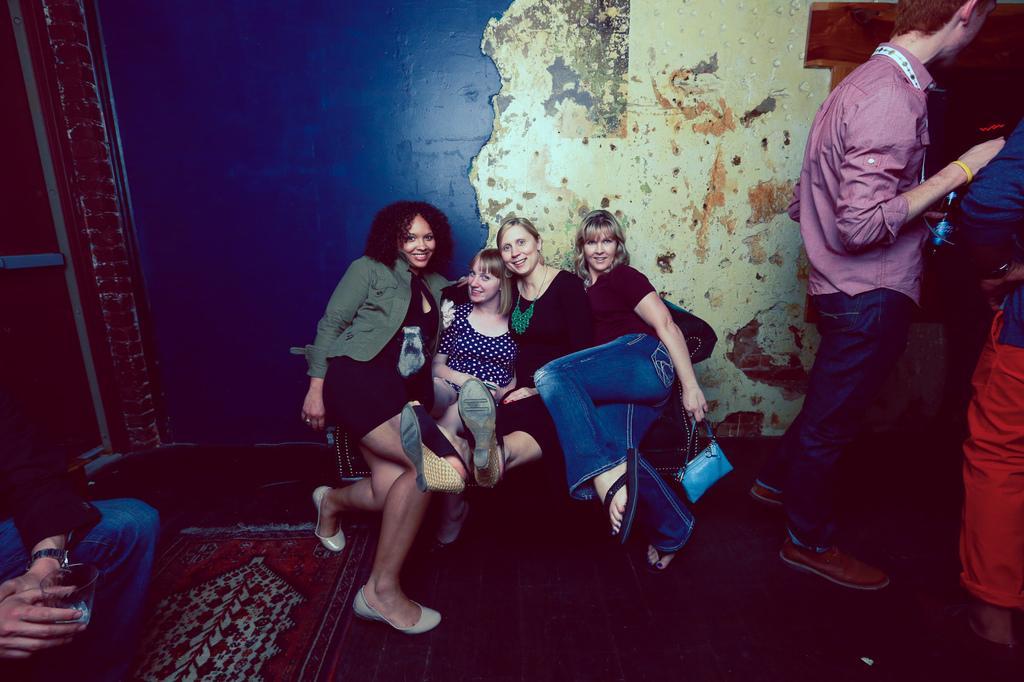Please provide a concise description of this image. The picture is clicked in a room. In the center of the picture there are four women sitting on a couch. On the left there is a man sitting on the couch. On the right there are two person standing. In the background it is well. 